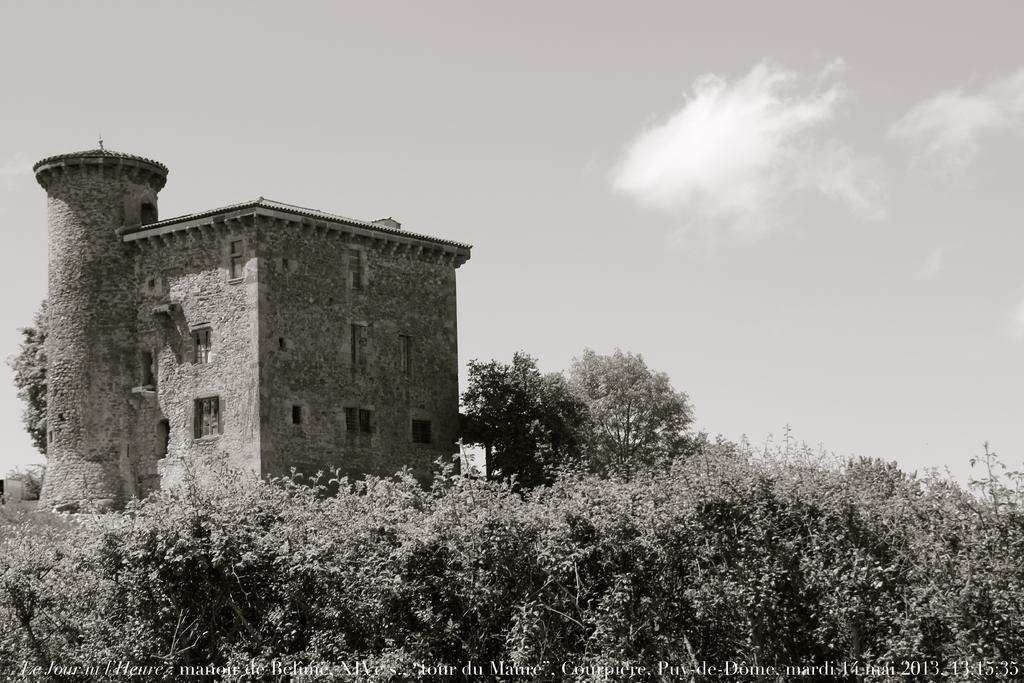Can you describe this image briefly? In this image I can see few trees, background I can see a building and sky, and the image is in black and white. 